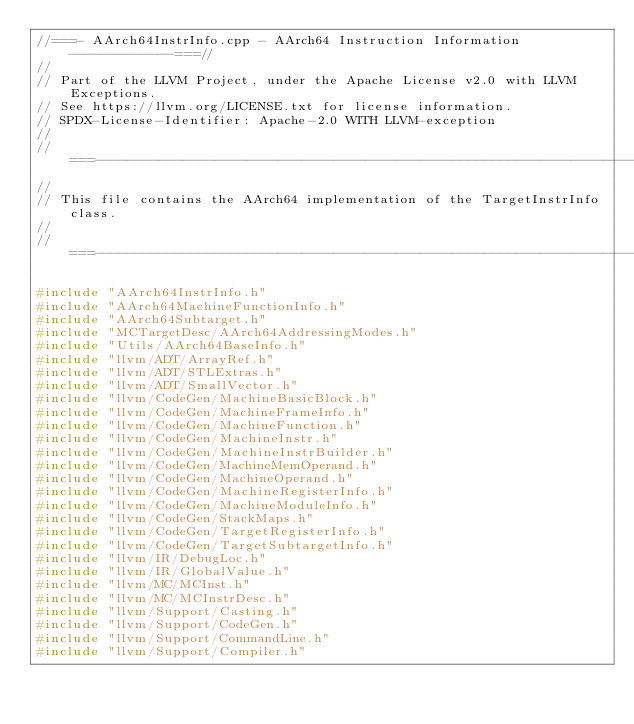<code> <loc_0><loc_0><loc_500><loc_500><_C++_>//===- AArch64InstrInfo.cpp - AArch64 Instruction Information -------------===//
//
// Part of the LLVM Project, under the Apache License v2.0 with LLVM Exceptions.
// See https://llvm.org/LICENSE.txt for license information.
// SPDX-License-Identifier: Apache-2.0 WITH LLVM-exception
//
//===----------------------------------------------------------------------===//
//
// This file contains the AArch64 implementation of the TargetInstrInfo class.
//
//===----------------------------------------------------------------------===//

#include "AArch64InstrInfo.h"
#include "AArch64MachineFunctionInfo.h"
#include "AArch64Subtarget.h"
#include "MCTargetDesc/AArch64AddressingModes.h"
#include "Utils/AArch64BaseInfo.h"
#include "llvm/ADT/ArrayRef.h"
#include "llvm/ADT/STLExtras.h"
#include "llvm/ADT/SmallVector.h"
#include "llvm/CodeGen/MachineBasicBlock.h"
#include "llvm/CodeGen/MachineFrameInfo.h"
#include "llvm/CodeGen/MachineFunction.h"
#include "llvm/CodeGen/MachineInstr.h"
#include "llvm/CodeGen/MachineInstrBuilder.h"
#include "llvm/CodeGen/MachineMemOperand.h"
#include "llvm/CodeGen/MachineOperand.h"
#include "llvm/CodeGen/MachineRegisterInfo.h"
#include "llvm/CodeGen/MachineModuleInfo.h"
#include "llvm/CodeGen/StackMaps.h"
#include "llvm/CodeGen/TargetRegisterInfo.h"
#include "llvm/CodeGen/TargetSubtargetInfo.h"
#include "llvm/IR/DebugLoc.h"
#include "llvm/IR/GlobalValue.h"
#include "llvm/MC/MCInst.h"
#include "llvm/MC/MCInstrDesc.h"
#include "llvm/Support/Casting.h"
#include "llvm/Support/CodeGen.h"
#include "llvm/Support/CommandLine.h"
#include "llvm/Support/Compiler.h"</code> 